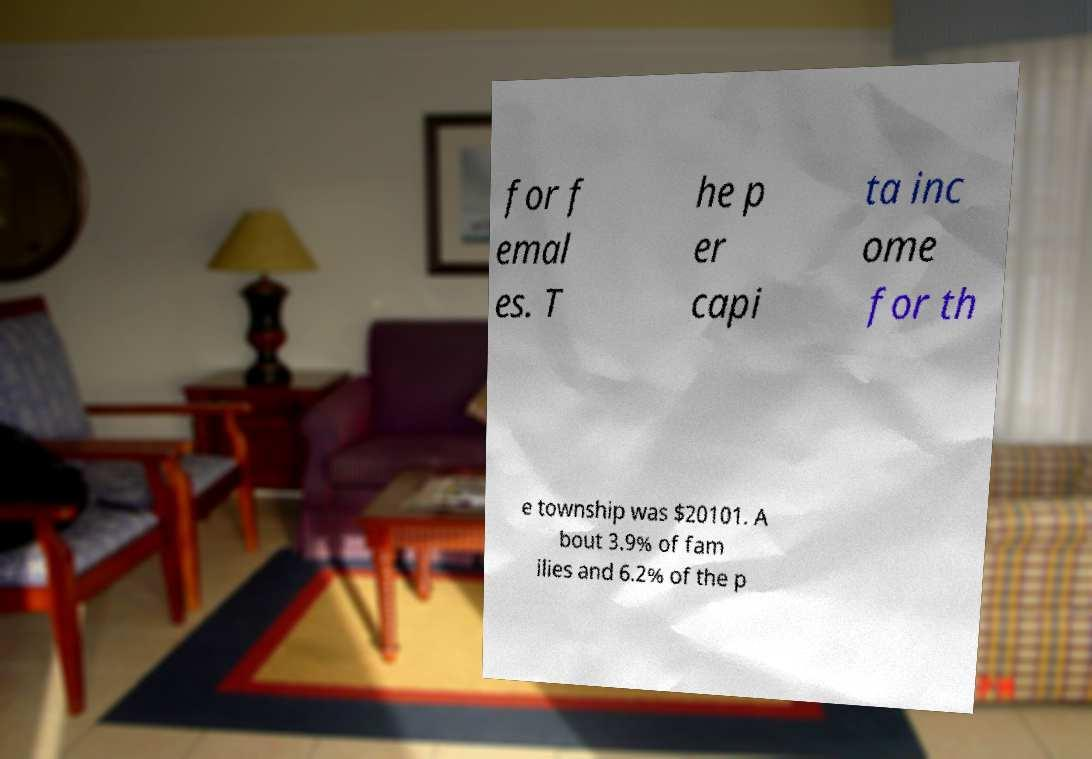Can you read and provide the text displayed in the image?This photo seems to have some interesting text. Can you extract and type it out for me? for f emal es. T he p er capi ta inc ome for th e township was $20101. A bout 3.9% of fam ilies and 6.2% of the p 